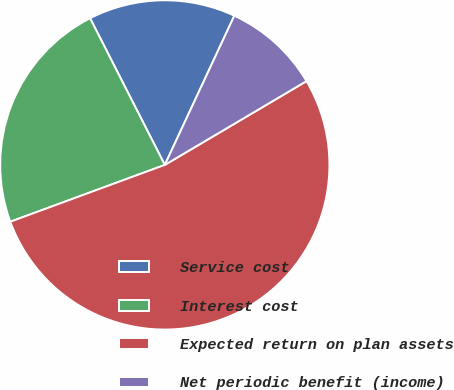Convert chart to OTSL. <chart><loc_0><loc_0><loc_500><loc_500><pie_chart><fcel>Service cost<fcel>Interest cost<fcel>Expected return on plan assets<fcel>Net periodic benefit (income)<nl><fcel>14.44%<fcel>23.11%<fcel>52.89%<fcel>9.56%<nl></chart> 